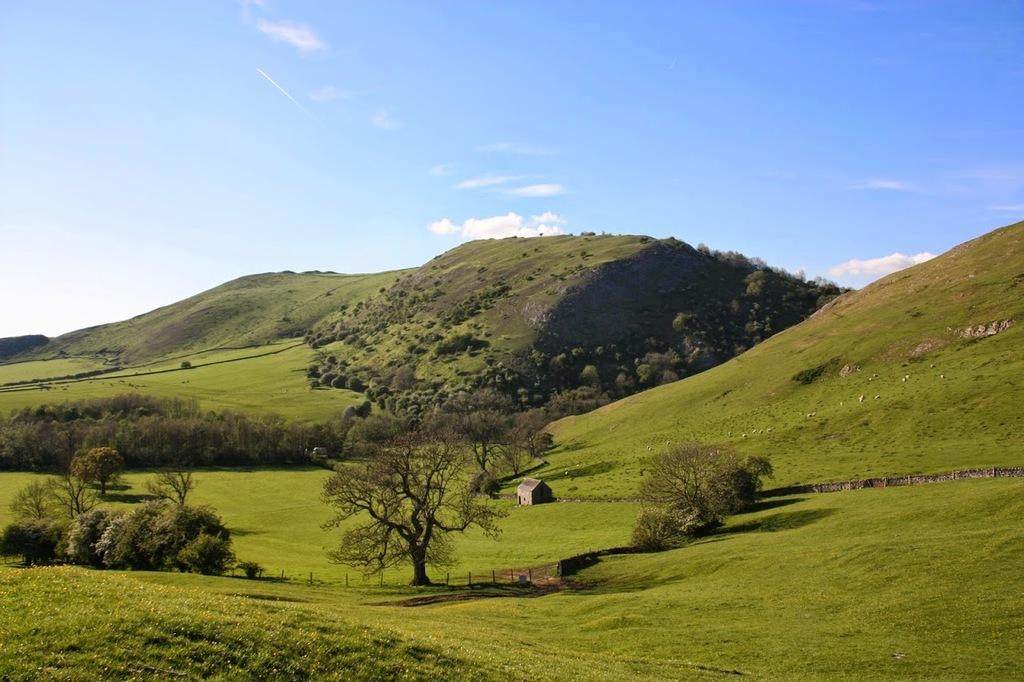What type of landscape is depicted in the image? There is a grassland in the image. What other natural elements can be seen in the image? There are trees and hills in the image. What man-made structure is present in the image? There is a house in the image. What is the color of the sky in the background? The sky is blue in the background. Are there any weather conditions visible in the image? Yes, there are clouds in the sky. What type of bed can be seen in the image? There is no bed present in the image. What emotion is being expressed by the love in the image? There is no love or emotion depicted in the image; it is a landscape scene. 